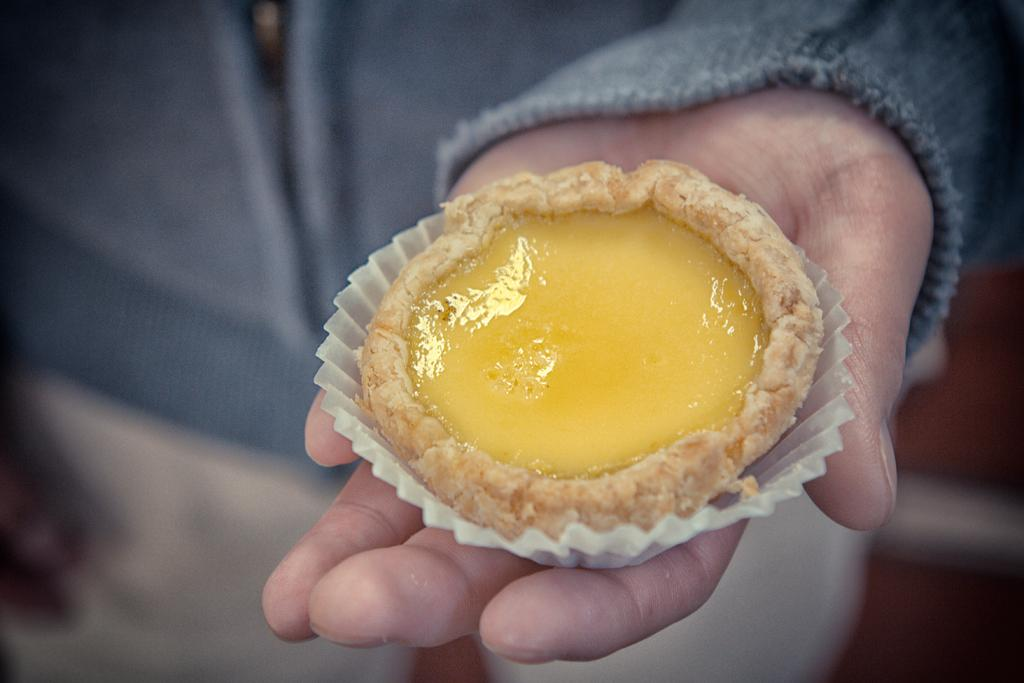What can be seen in the image related to a person's hand? There is a person's hand in the image. What type of food is visible in the image? There is a cupcake in the image. What type of plants can be seen growing on the person's hand in the image? There are no plants visible on the person's hand in the image. Can you see a cobweb in the image? There is no cobweb present in the image. 